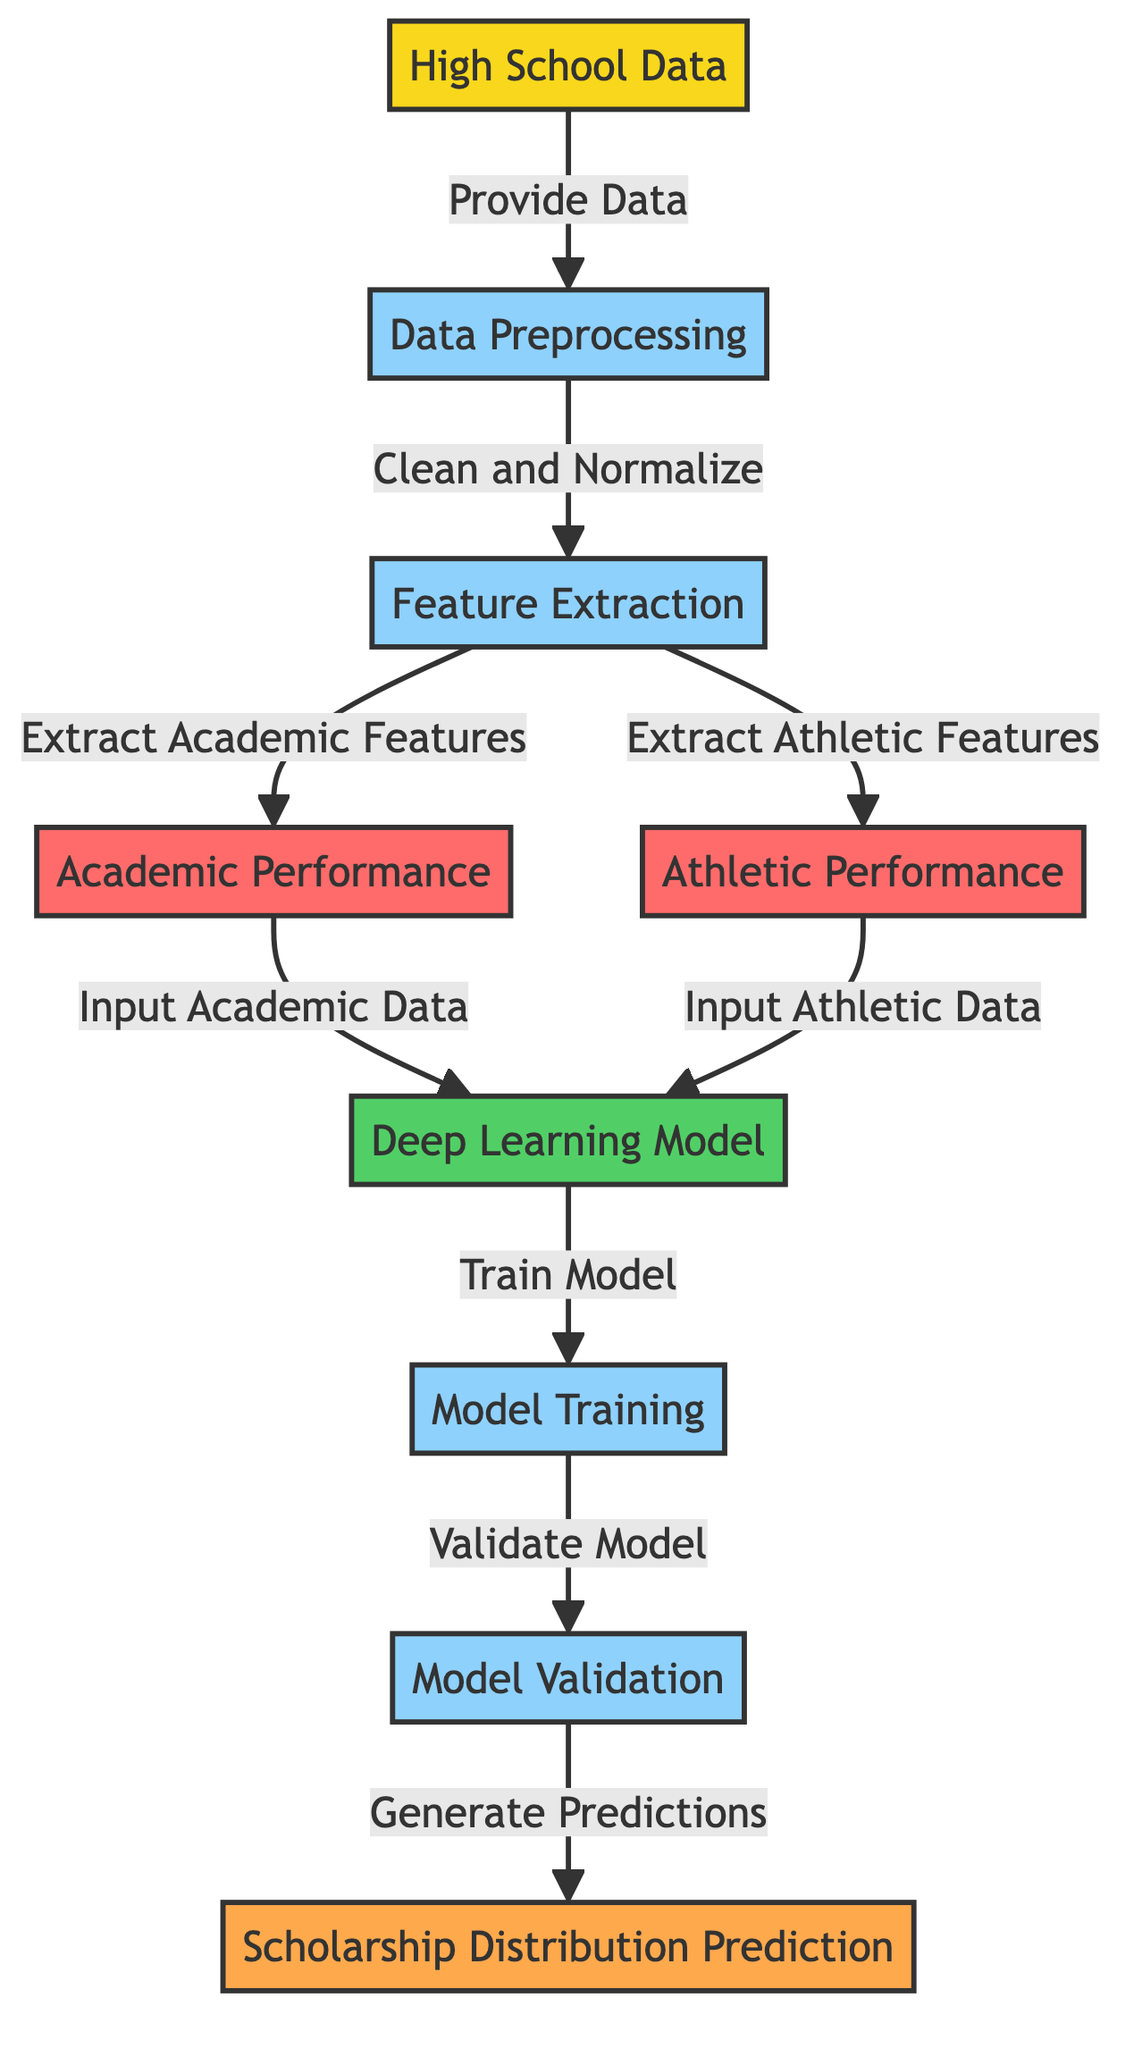What is the first step in the diagram? The first step in the diagram is "High School Data". It is the starting point from which all other processes derive their input data.
Answer: High School Data How many process nodes are in the diagram? There are four process nodes: "Data Preprocessing", "Feature Extraction", "Model Training", and "Model Validation". Count each unique process box to arrive at the total.
Answer: Four What type of model is used in this diagram? The model used in the diagram is a "Deep Learning Model". It is highlighted as the main component where the data is fed for training and prediction.
Answer: Deep Learning Model What is extracted during the "Feature Extraction" step? During the "Feature Extraction" step, both "Academic Performance" and "Athletic Performance" features are extracted. This indicates that the data is being categorized into two distinct areas of performance.
Answer: Academic Performance and Athletic Performance What does the "Model Validation" step generate? The "Model Validation" step generates predictions for "Scholarship Distribution". This step is crucial for assessing the model's ability to predict outcomes accurately based on the training it received.
Answer: Scholarship Distribution Prediction Which node receives input from "Academic Performance"? The node that receives input from "Academic Performance" is the "Deep Learning Model". This indicates that academic metrics specifically contribute to model training.
Answer: Deep Learning Model What follows immediately after "Data Preprocessing"? Immediately after "Data Preprocessing", the next step is "Feature Extraction". This flow represents the sequential process in a machine learning pipeline where data is cleaned and then processed for feature extraction.
Answer: Feature Extraction What links "Model Training" and "Model Validation"? The link between "Model Training" and "Model Validation" is the "Train Model" arrow which shows the progression from training the deep learning model to validating its performance.
Answer: Train Model What is the final output of this machine learning diagram? The final output indicated in the diagram is "Scholarship Distribution Prediction". This serves as the result of the entire process laid out in the diagram, showing the end goal of the analysis.
Answer: Scholarship Distribution Prediction 